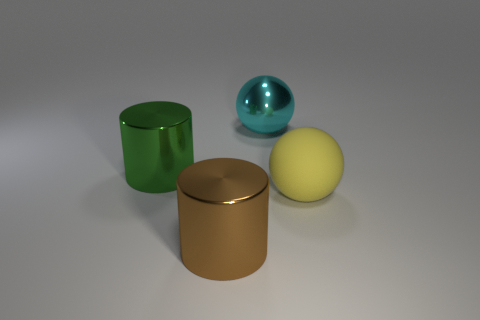What is the shape of the cyan object that is the same size as the yellow sphere?
Offer a terse response. Sphere. What number of green things are either big shiny cylinders or large rubber cubes?
Offer a very short reply. 1. What number of other cyan shiny spheres have the same size as the metallic sphere?
Offer a very short reply. 0. How many things are cyan balls or large objects that are right of the large green shiny thing?
Offer a terse response. 3. What number of other large things are the same shape as the big brown metallic thing?
Keep it short and to the point. 1. What is the shape of the green object that is made of the same material as the large cyan object?
Give a very brief answer. Cylinder. There is a sphere that is in front of the sphere behind the sphere that is to the right of the shiny ball; what is its material?
Offer a terse response. Rubber. What material is the other big thing that is the same shape as the green object?
Keep it short and to the point. Metal. Is the size of the metallic sphere the same as the brown metallic cylinder?
Offer a terse response. Yes. There is a big ball that is in front of the large sphere behind the green metal object; what is it made of?
Give a very brief answer. Rubber. 